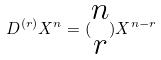Convert formula to latex. <formula><loc_0><loc_0><loc_500><loc_500>D ^ { ( r ) } X ^ { n } = ( \begin{matrix} n \\ r \end{matrix} ) X ^ { n - r }</formula> 